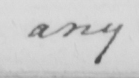Please transcribe the handwritten text in this image. any 